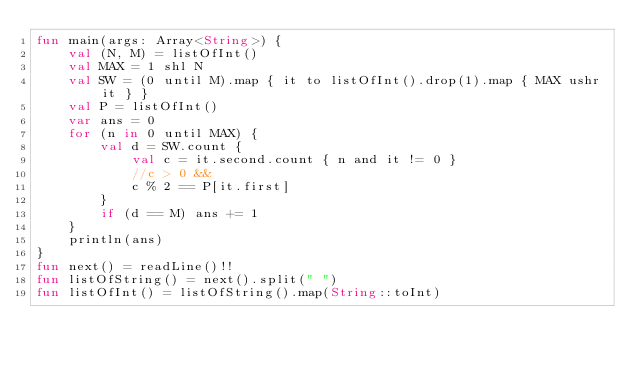<code> <loc_0><loc_0><loc_500><loc_500><_Kotlin_>fun main(args: Array<String>) {
    val (N, M) = listOfInt()
    val MAX = 1 shl N
    val SW = (0 until M).map { it to listOfInt().drop(1).map { MAX ushr it } }
    val P = listOfInt()
    var ans = 0
    for (n in 0 until MAX) {
        val d = SW.count {
            val c = it.second.count { n and it != 0 }
            //c > 0 &&
            c % 2 == P[it.first]
        }
        if (d == M) ans += 1
    }
    println(ans)
}
fun next() = readLine()!!
fun listOfString() = next().split(" ")
fun listOfInt() = listOfString().map(String::toInt)</code> 